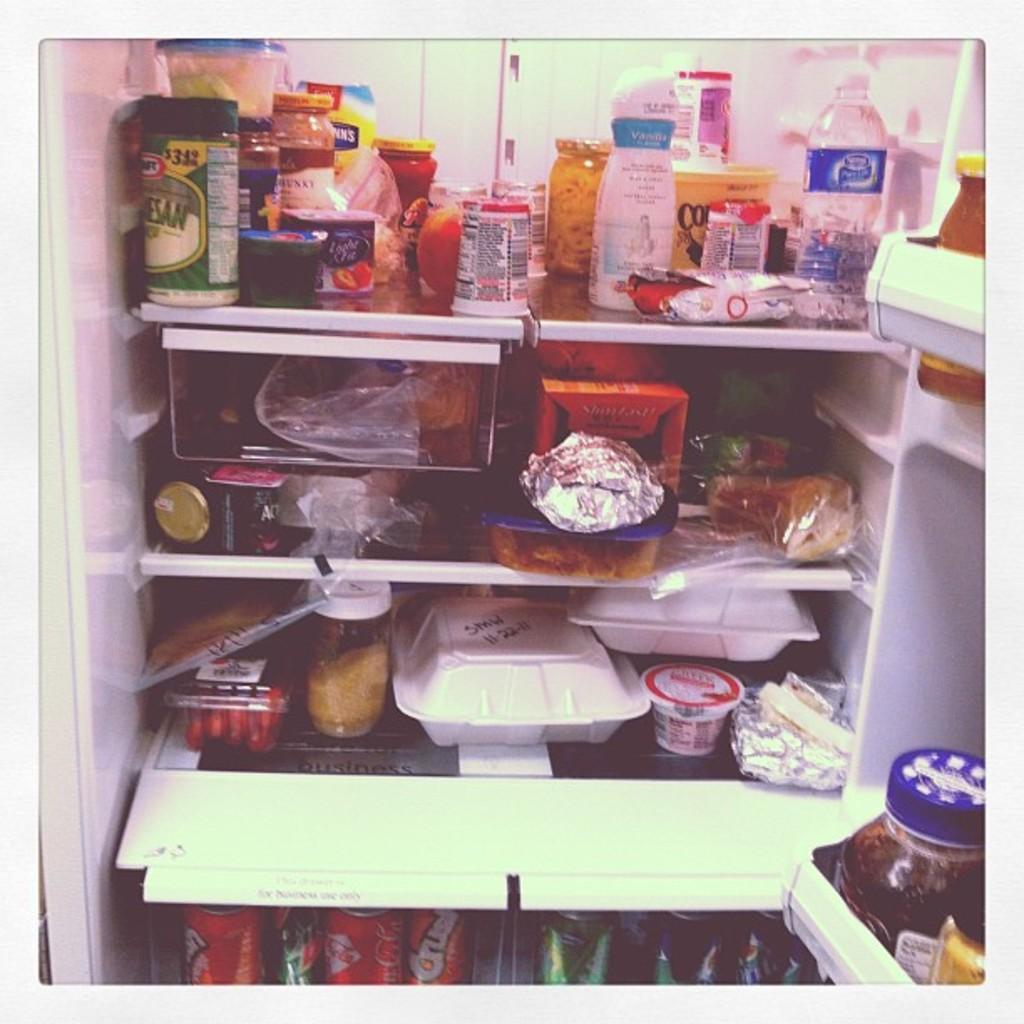Please provide a concise description of this image. In the picture there is a fridge. It contains four shelves. On the bottom there is a coke cans. On the top we can see a water bottle, cup and boxes. On the top right there is a honey bottle. 